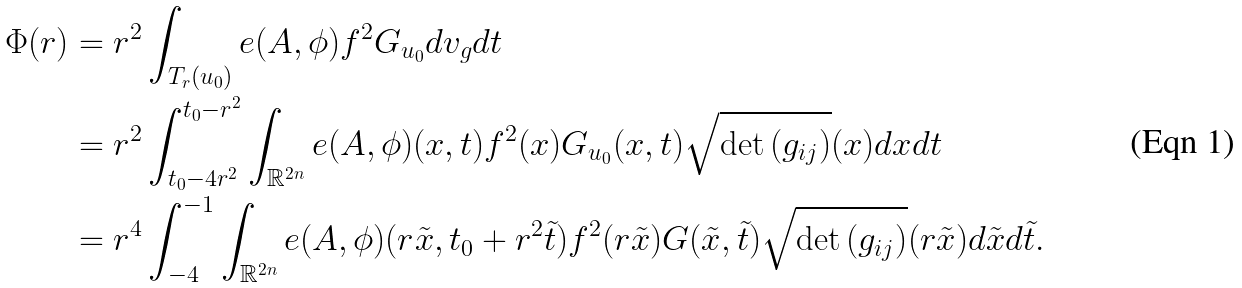<formula> <loc_0><loc_0><loc_500><loc_500>\Phi ( r ) & = r ^ { 2 } \int _ { T _ { r } ( u _ { 0 } ) } e ( A , \phi ) f ^ { 2 } G _ { u _ { 0 } } d v _ { g } d t \\ & = r ^ { 2 } \int _ { t _ { 0 } - 4 r ^ { 2 } } ^ { t _ { 0 } - r ^ { 2 } } \int _ { \mathbb { R } ^ { 2 n } } e ( A , \phi ) ( x , t ) f ^ { 2 } ( x ) G _ { u _ { 0 } } ( x , t ) \sqrt { \det { ( g _ { i j } ) } } ( x ) d x d t \\ & = r ^ { 4 } \int _ { - 4 } ^ { - 1 } \int _ { \mathbb { R } ^ { 2 n } } e ( A , \phi ) ( r \tilde { x } , t _ { 0 } + r ^ { 2 } \tilde { t } ) f ^ { 2 } ( r \tilde { x } ) G ( \tilde { x } , \tilde { t } ) \sqrt { \det { ( g _ { i j } ) } } ( r \tilde { x } ) d \tilde { x } d \tilde { t } .</formula> 